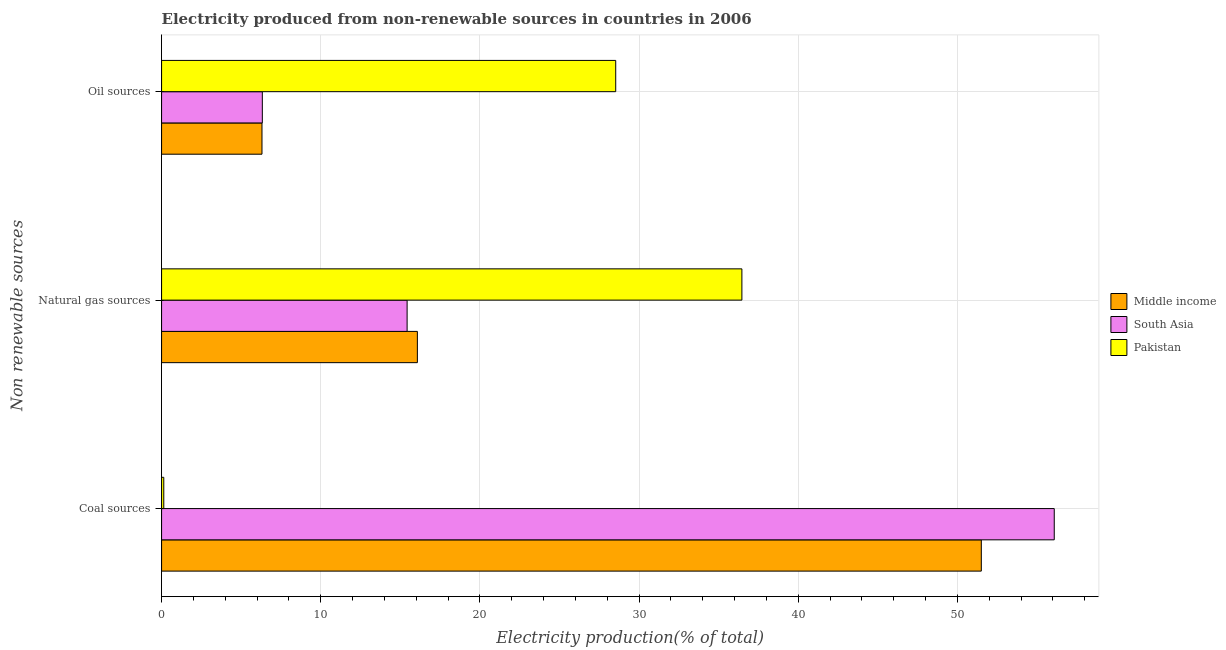How many different coloured bars are there?
Your response must be concise. 3. How many groups of bars are there?
Give a very brief answer. 3. Are the number of bars per tick equal to the number of legend labels?
Your response must be concise. Yes. Are the number of bars on each tick of the Y-axis equal?
Your response must be concise. Yes. How many bars are there on the 2nd tick from the top?
Make the answer very short. 3. How many bars are there on the 3rd tick from the bottom?
Your answer should be compact. 3. What is the label of the 2nd group of bars from the top?
Make the answer very short. Natural gas sources. What is the percentage of electricity produced by oil sources in South Asia?
Offer a terse response. 6.33. Across all countries, what is the maximum percentage of electricity produced by coal?
Offer a very short reply. 56.09. Across all countries, what is the minimum percentage of electricity produced by coal?
Your response must be concise. 0.14. What is the total percentage of electricity produced by oil sources in the graph?
Offer a terse response. 41.17. What is the difference between the percentage of electricity produced by oil sources in South Asia and that in Middle income?
Your response must be concise. 0.02. What is the difference between the percentage of electricity produced by oil sources in Middle income and the percentage of electricity produced by natural gas in South Asia?
Your response must be concise. -9.12. What is the average percentage of electricity produced by oil sources per country?
Provide a short and direct response. 13.72. What is the difference between the percentage of electricity produced by oil sources and percentage of electricity produced by natural gas in South Asia?
Your response must be concise. -9.1. In how many countries, is the percentage of electricity produced by natural gas greater than 8 %?
Offer a terse response. 3. What is the ratio of the percentage of electricity produced by coal in South Asia to that in Middle income?
Offer a very short reply. 1.09. Is the percentage of electricity produced by coal in South Asia less than that in Middle income?
Your answer should be compact. No. What is the difference between the highest and the second highest percentage of electricity produced by natural gas?
Offer a terse response. 20.39. What is the difference between the highest and the lowest percentage of electricity produced by oil sources?
Provide a short and direct response. 22.23. In how many countries, is the percentage of electricity produced by natural gas greater than the average percentage of electricity produced by natural gas taken over all countries?
Your answer should be very brief. 1. Is the sum of the percentage of electricity produced by natural gas in Middle income and South Asia greater than the maximum percentage of electricity produced by oil sources across all countries?
Give a very brief answer. Yes. How many bars are there?
Ensure brevity in your answer.  9. How many countries are there in the graph?
Provide a succinct answer. 3. What is the difference between two consecutive major ticks on the X-axis?
Keep it short and to the point. 10. Does the graph contain any zero values?
Keep it short and to the point. No. What is the title of the graph?
Your answer should be very brief. Electricity produced from non-renewable sources in countries in 2006. What is the label or title of the Y-axis?
Give a very brief answer. Non renewable sources. What is the Electricity production(% of total) in Middle income in Coal sources?
Your answer should be compact. 51.51. What is the Electricity production(% of total) in South Asia in Coal sources?
Your answer should be very brief. 56.09. What is the Electricity production(% of total) in Pakistan in Coal sources?
Your answer should be compact. 0.14. What is the Electricity production(% of total) in Middle income in Natural gas sources?
Provide a succinct answer. 16.07. What is the Electricity production(% of total) in South Asia in Natural gas sources?
Provide a succinct answer. 15.43. What is the Electricity production(% of total) in Pakistan in Natural gas sources?
Your response must be concise. 36.46. What is the Electricity production(% of total) in Middle income in Oil sources?
Give a very brief answer. 6.31. What is the Electricity production(% of total) in South Asia in Oil sources?
Your answer should be compact. 6.33. What is the Electricity production(% of total) in Pakistan in Oil sources?
Your answer should be very brief. 28.53. Across all Non renewable sources, what is the maximum Electricity production(% of total) in Middle income?
Your answer should be very brief. 51.51. Across all Non renewable sources, what is the maximum Electricity production(% of total) in South Asia?
Give a very brief answer. 56.09. Across all Non renewable sources, what is the maximum Electricity production(% of total) in Pakistan?
Ensure brevity in your answer.  36.46. Across all Non renewable sources, what is the minimum Electricity production(% of total) of Middle income?
Offer a terse response. 6.31. Across all Non renewable sources, what is the minimum Electricity production(% of total) of South Asia?
Your response must be concise. 6.33. Across all Non renewable sources, what is the minimum Electricity production(% of total) of Pakistan?
Give a very brief answer. 0.14. What is the total Electricity production(% of total) of Middle income in the graph?
Ensure brevity in your answer.  73.89. What is the total Electricity production(% of total) in South Asia in the graph?
Offer a very short reply. 77.85. What is the total Electricity production(% of total) in Pakistan in the graph?
Offer a terse response. 65.14. What is the difference between the Electricity production(% of total) of Middle income in Coal sources and that in Natural gas sources?
Provide a succinct answer. 35.43. What is the difference between the Electricity production(% of total) of South Asia in Coal sources and that in Natural gas sources?
Give a very brief answer. 40.66. What is the difference between the Electricity production(% of total) of Pakistan in Coal sources and that in Natural gas sources?
Provide a succinct answer. -36.32. What is the difference between the Electricity production(% of total) in Middle income in Coal sources and that in Oil sources?
Keep it short and to the point. 45.2. What is the difference between the Electricity production(% of total) of South Asia in Coal sources and that in Oil sources?
Keep it short and to the point. 49.76. What is the difference between the Electricity production(% of total) in Pakistan in Coal sources and that in Oil sources?
Provide a short and direct response. -28.4. What is the difference between the Electricity production(% of total) in Middle income in Natural gas sources and that in Oil sources?
Give a very brief answer. 9.76. What is the difference between the Electricity production(% of total) of South Asia in Natural gas sources and that in Oil sources?
Give a very brief answer. 9.1. What is the difference between the Electricity production(% of total) in Pakistan in Natural gas sources and that in Oil sources?
Keep it short and to the point. 7.93. What is the difference between the Electricity production(% of total) of Middle income in Coal sources and the Electricity production(% of total) of South Asia in Natural gas sources?
Your response must be concise. 36.08. What is the difference between the Electricity production(% of total) in Middle income in Coal sources and the Electricity production(% of total) in Pakistan in Natural gas sources?
Provide a succinct answer. 15.04. What is the difference between the Electricity production(% of total) of South Asia in Coal sources and the Electricity production(% of total) of Pakistan in Natural gas sources?
Keep it short and to the point. 19.63. What is the difference between the Electricity production(% of total) in Middle income in Coal sources and the Electricity production(% of total) in South Asia in Oil sources?
Offer a very short reply. 45.17. What is the difference between the Electricity production(% of total) in Middle income in Coal sources and the Electricity production(% of total) in Pakistan in Oil sources?
Offer a very short reply. 22.97. What is the difference between the Electricity production(% of total) in South Asia in Coal sources and the Electricity production(% of total) in Pakistan in Oil sources?
Offer a terse response. 27.55. What is the difference between the Electricity production(% of total) of Middle income in Natural gas sources and the Electricity production(% of total) of South Asia in Oil sources?
Your response must be concise. 9.74. What is the difference between the Electricity production(% of total) in Middle income in Natural gas sources and the Electricity production(% of total) in Pakistan in Oil sources?
Ensure brevity in your answer.  -12.46. What is the difference between the Electricity production(% of total) in South Asia in Natural gas sources and the Electricity production(% of total) in Pakistan in Oil sources?
Provide a short and direct response. -13.11. What is the average Electricity production(% of total) in Middle income per Non renewable sources?
Your answer should be very brief. 24.63. What is the average Electricity production(% of total) in South Asia per Non renewable sources?
Provide a succinct answer. 25.95. What is the average Electricity production(% of total) of Pakistan per Non renewable sources?
Provide a short and direct response. 21.71. What is the difference between the Electricity production(% of total) in Middle income and Electricity production(% of total) in South Asia in Coal sources?
Keep it short and to the point. -4.58. What is the difference between the Electricity production(% of total) of Middle income and Electricity production(% of total) of Pakistan in Coal sources?
Offer a very short reply. 51.37. What is the difference between the Electricity production(% of total) of South Asia and Electricity production(% of total) of Pakistan in Coal sources?
Your response must be concise. 55.95. What is the difference between the Electricity production(% of total) of Middle income and Electricity production(% of total) of South Asia in Natural gas sources?
Your response must be concise. 0.65. What is the difference between the Electricity production(% of total) in Middle income and Electricity production(% of total) in Pakistan in Natural gas sources?
Offer a very short reply. -20.39. What is the difference between the Electricity production(% of total) in South Asia and Electricity production(% of total) in Pakistan in Natural gas sources?
Your response must be concise. -21.04. What is the difference between the Electricity production(% of total) in Middle income and Electricity production(% of total) in South Asia in Oil sources?
Provide a succinct answer. -0.02. What is the difference between the Electricity production(% of total) of Middle income and Electricity production(% of total) of Pakistan in Oil sources?
Your response must be concise. -22.23. What is the difference between the Electricity production(% of total) of South Asia and Electricity production(% of total) of Pakistan in Oil sources?
Your response must be concise. -22.2. What is the ratio of the Electricity production(% of total) of Middle income in Coal sources to that in Natural gas sources?
Make the answer very short. 3.2. What is the ratio of the Electricity production(% of total) of South Asia in Coal sources to that in Natural gas sources?
Give a very brief answer. 3.64. What is the ratio of the Electricity production(% of total) in Pakistan in Coal sources to that in Natural gas sources?
Keep it short and to the point. 0. What is the ratio of the Electricity production(% of total) of Middle income in Coal sources to that in Oil sources?
Offer a very short reply. 8.16. What is the ratio of the Electricity production(% of total) in South Asia in Coal sources to that in Oil sources?
Your answer should be very brief. 8.86. What is the ratio of the Electricity production(% of total) in Pakistan in Coal sources to that in Oil sources?
Your response must be concise. 0. What is the ratio of the Electricity production(% of total) in Middle income in Natural gas sources to that in Oil sources?
Give a very brief answer. 2.55. What is the ratio of the Electricity production(% of total) of South Asia in Natural gas sources to that in Oil sources?
Provide a short and direct response. 2.44. What is the ratio of the Electricity production(% of total) of Pakistan in Natural gas sources to that in Oil sources?
Ensure brevity in your answer.  1.28. What is the difference between the highest and the second highest Electricity production(% of total) of Middle income?
Your answer should be very brief. 35.43. What is the difference between the highest and the second highest Electricity production(% of total) of South Asia?
Your answer should be compact. 40.66. What is the difference between the highest and the second highest Electricity production(% of total) of Pakistan?
Make the answer very short. 7.93. What is the difference between the highest and the lowest Electricity production(% of total) in Middle income?
Make the answer very short. 45.2. What is the difference between the highest and the lowest Electricity production(% of total) in South Asia?
Provide a short and direct response. 49.76. What is the difference between the highest and the lowest Electricity production(% of total) of Pakistan?
Provide a succinct answer. 36.32. 